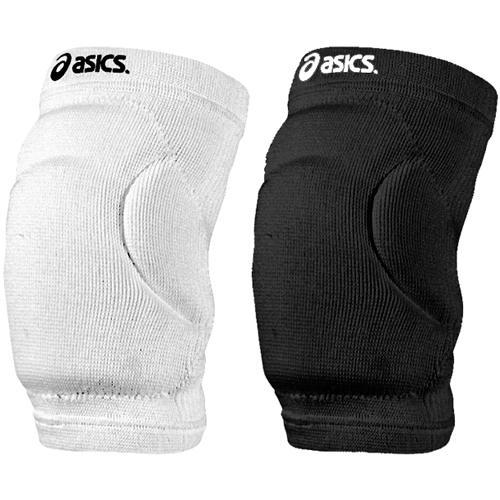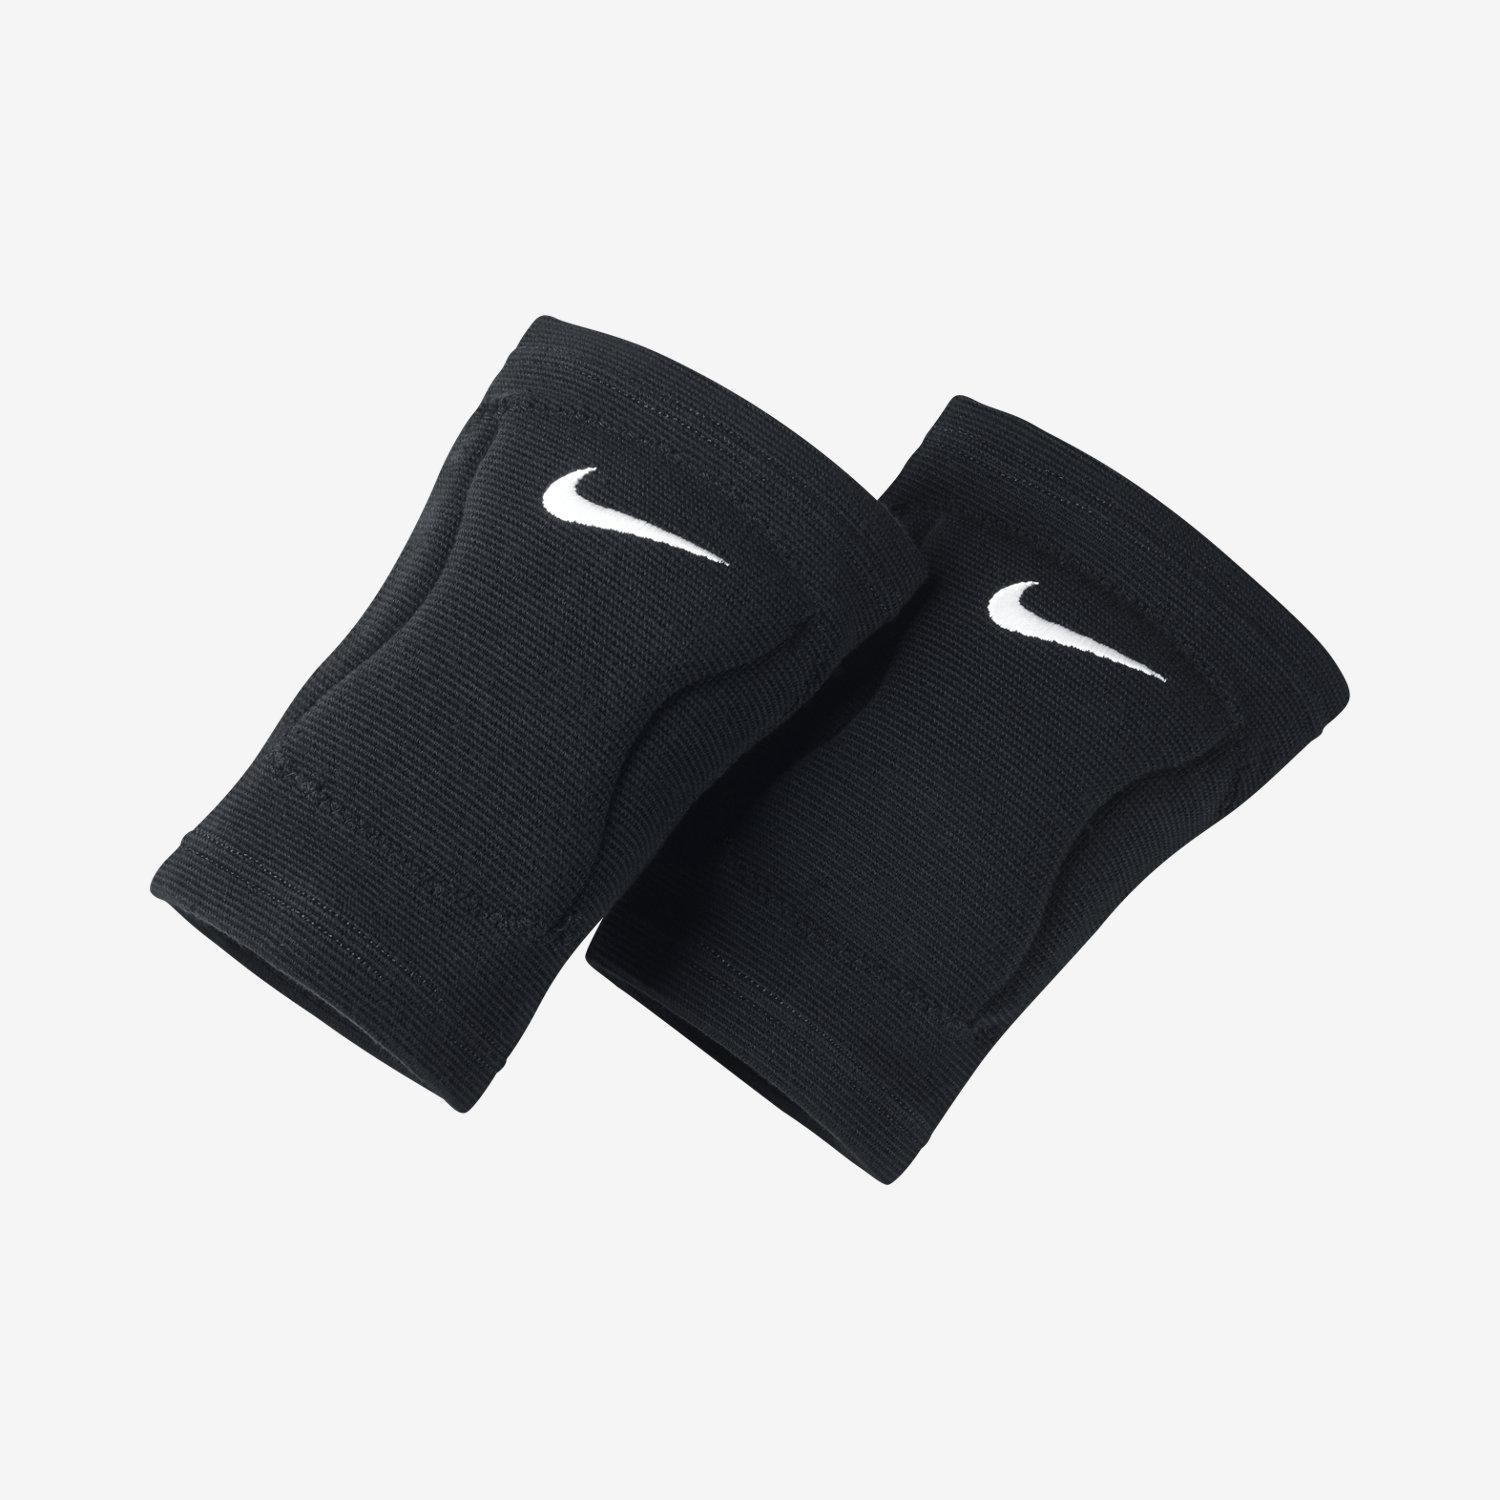The first image is the image on the left, the second image is the image on the right. Assess this claim about the two images: "There are both black and white knee pads". Correct or not? Answer yes or no. Yes. The first image is the image on the left, the second image is the image on the right. Considering the images on both sides, is "At least one white knee brace with black logo is shown in one image." valid? Answer yes or no. Yes. 